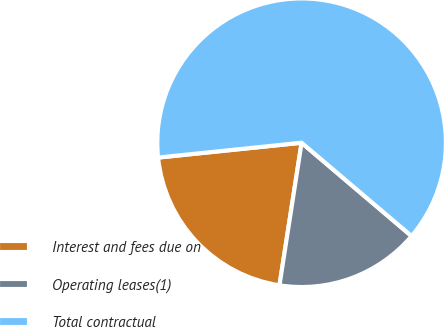Convert chart to OTSL. <chart><loc_0><loc_0><loc_500><loc_500><pie_chart><fcel>Interest and fees due on<fcel>Operating leases(1)<fcel>Total contractual<nl><fcel>20.91%<fcel>16.25%<fcel>62.84%<nl></chart> 